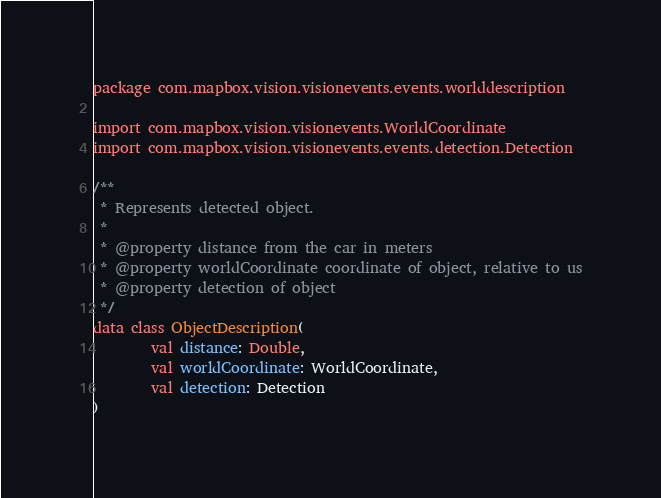Convert code to text. <code><loc_0><loc_0><loc_500><loc_500><_Kotlin_>package com.mapbox.vision.visionevents.events.worlddescription

import com.mapbox.vision.visionevents.WorldCoordinate
import com.mapbox.vision.visionevents.events.detection.Detection

/**
 * Represents detected object.
 *
 * @property distance from the car in meters
 * @property worldCoordinate coordinate of object, relative to us
 * @property detection of object
 */
data class ObjectDescription(
        val distance: Double,
        val worldCoordinate: WorldCoordinate,
        val detection: Detection
)
</code> 